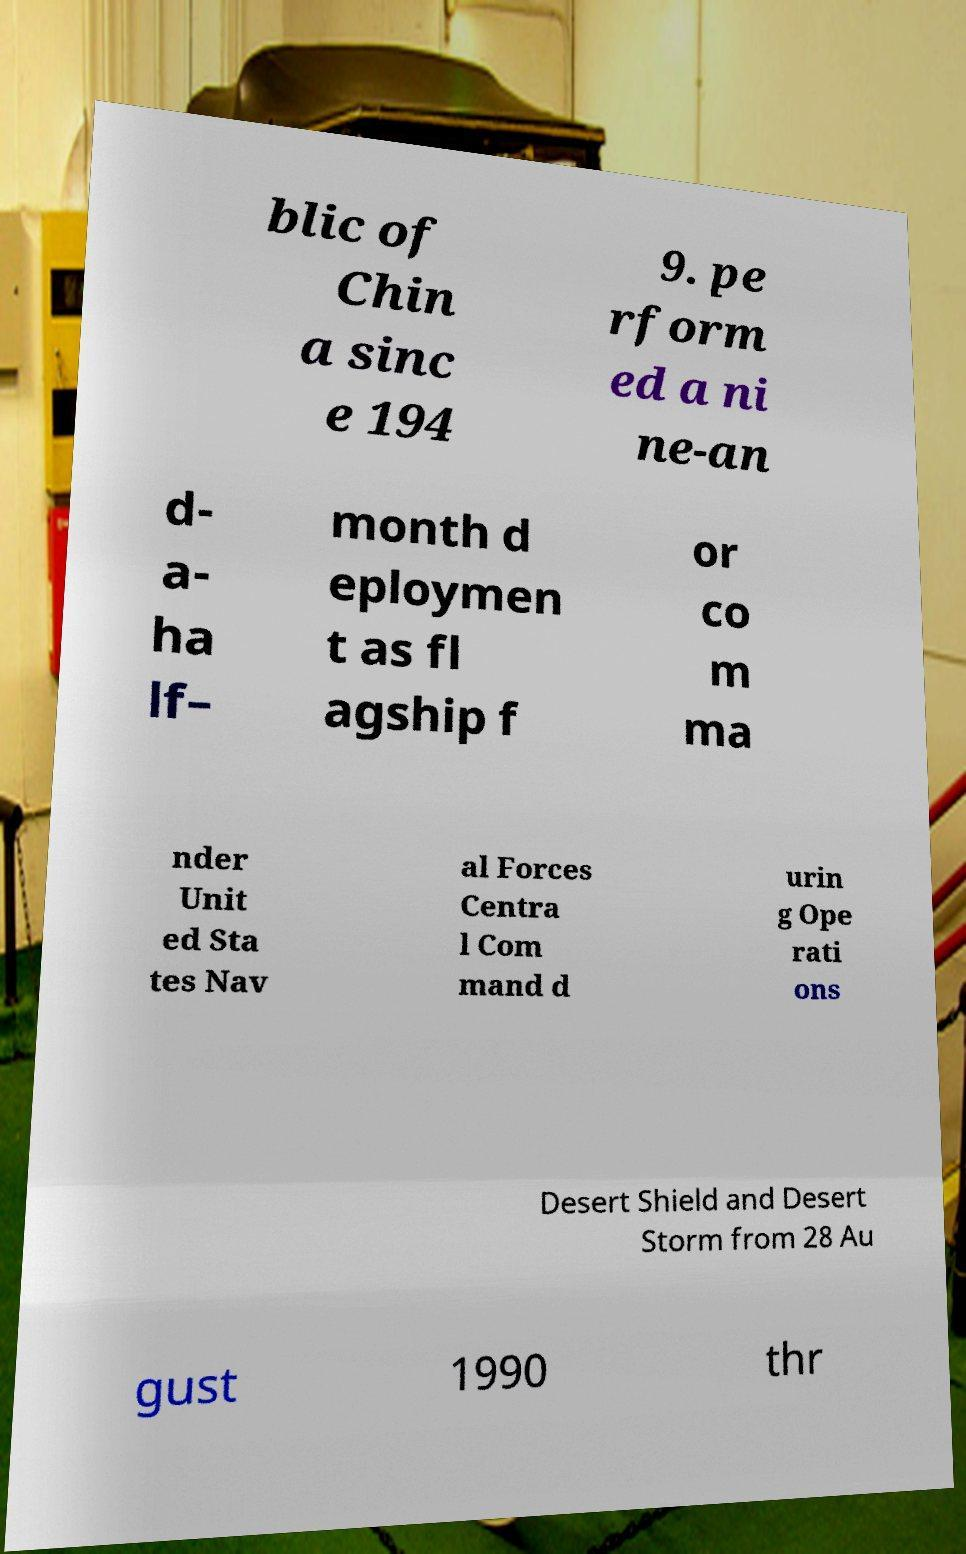I need the written content from this picture converted into text. Can you do that? blic of Chin a sinc e 194 9. pe rform ed a ni ne-an d- a- ha lf– month d eploymen t as fl agship f or co m ma nder Unit ed Sta tes Nav al Forces Centra l Com mand d urin g Ope rati ons Desert Shield and Desert Storm from 28 Au gust 1990 thr 